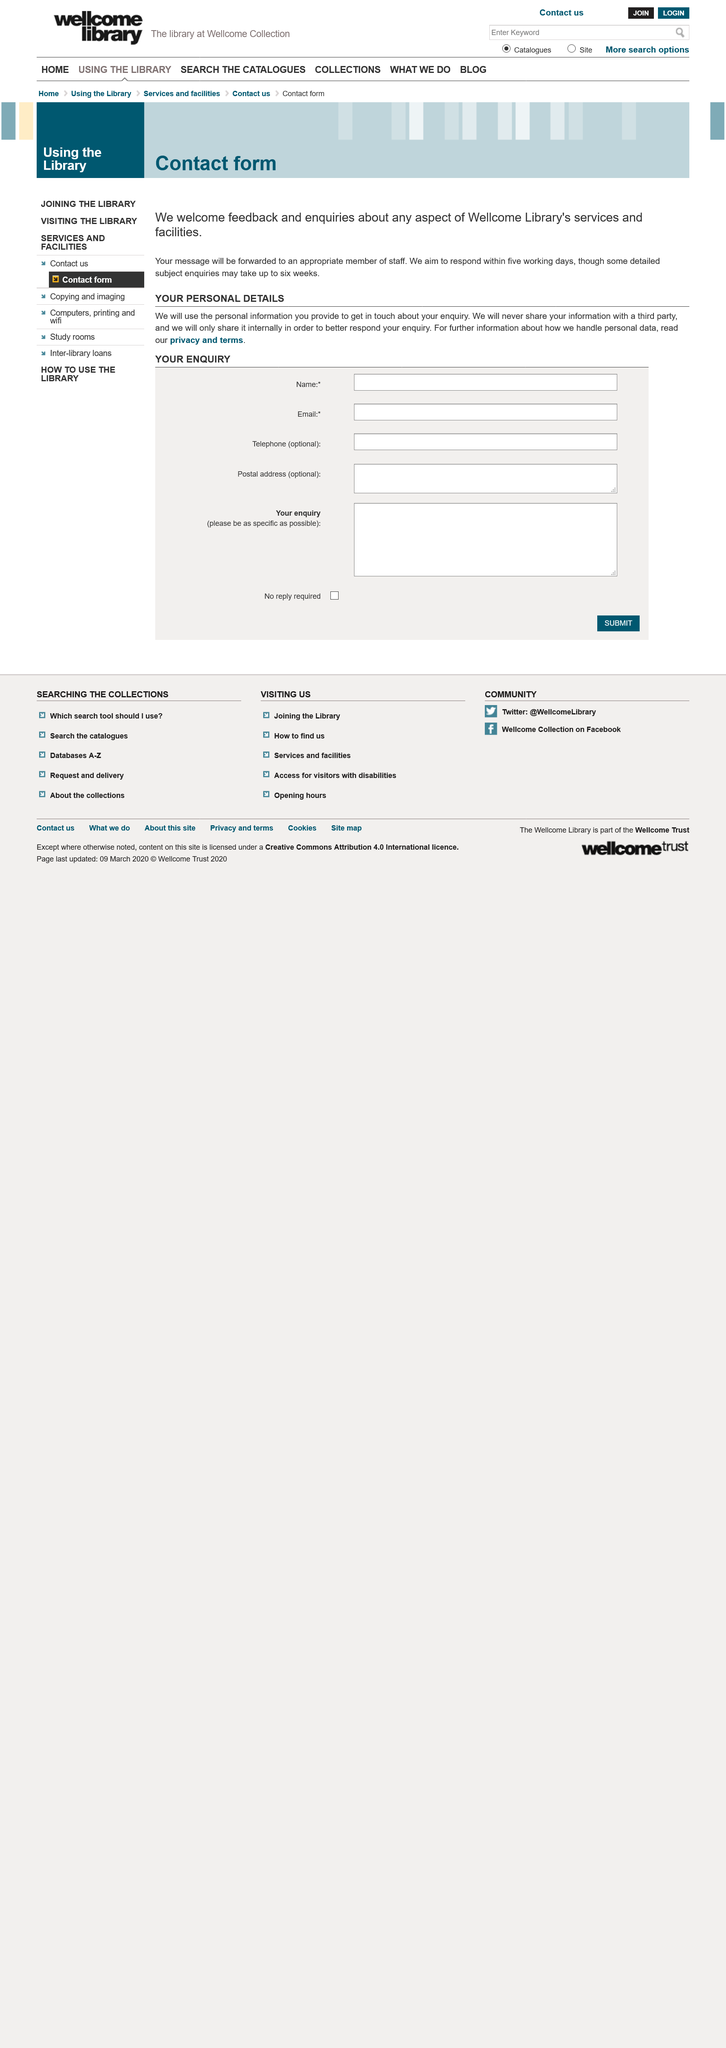Give some essential details in this illustration. We will not share any personal details with third parties. This contact form is intended for the purposes of inquiring about the services and facilities offered by the Wellcome Library. It may take between 5 working days and 6 weeks for a response. 